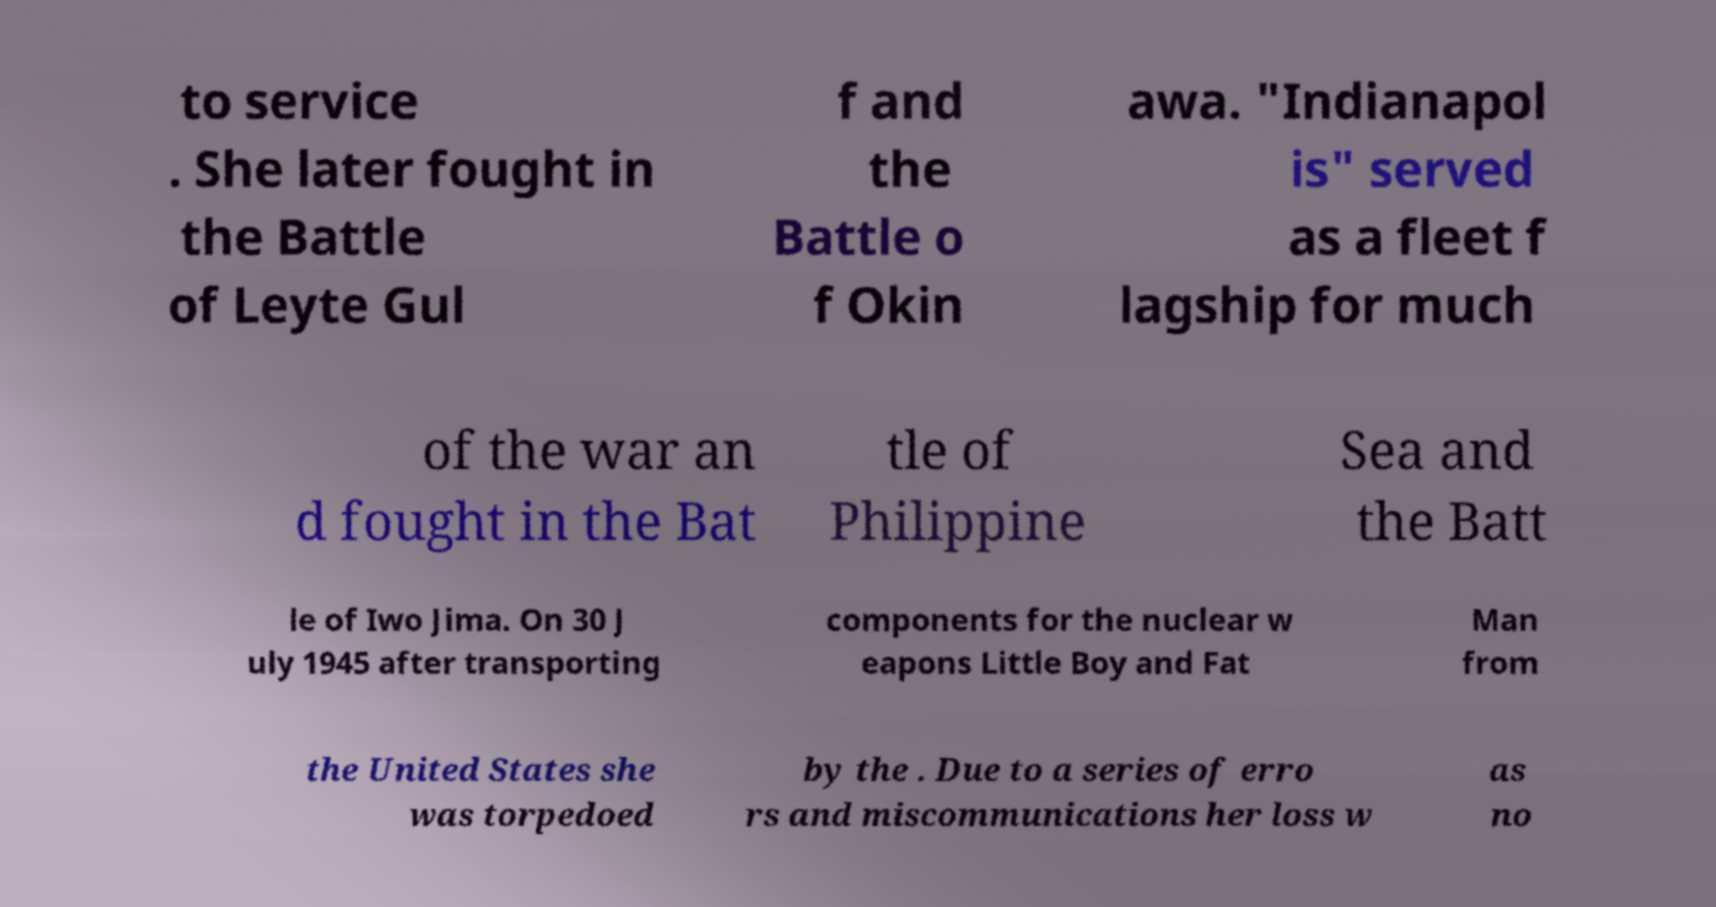I need the written content from this picture converted into text. Can you do that? to service . She later fought in the Battle of Leyte Gul f and the Battle o f Okin awa. "Indianapol is" served as a fleet f lagship for much of the war an d fought in the Bat tle of Philippine Sea and the Batt le of Iwo Jima. On 30 J uly 1945 after transporting components for the nuclear w eapons Little Boy and Fat Man from the United States she was torpedoed by the . Due to a series of erro rs and miscommunications her loss w as no 